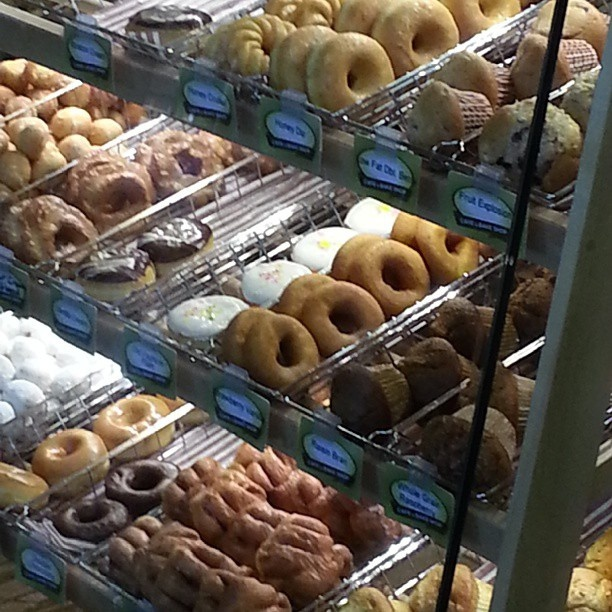Describe the objects in this image and their specific colors. I can see donut in black, olive, tan, and gray tones, donut in black, maroon, and gray tones, donut in black, gray, and maroon tones, donut in black, maroon, and gray tones, and donut in black, maroon, gray, and tan tones in this image. 